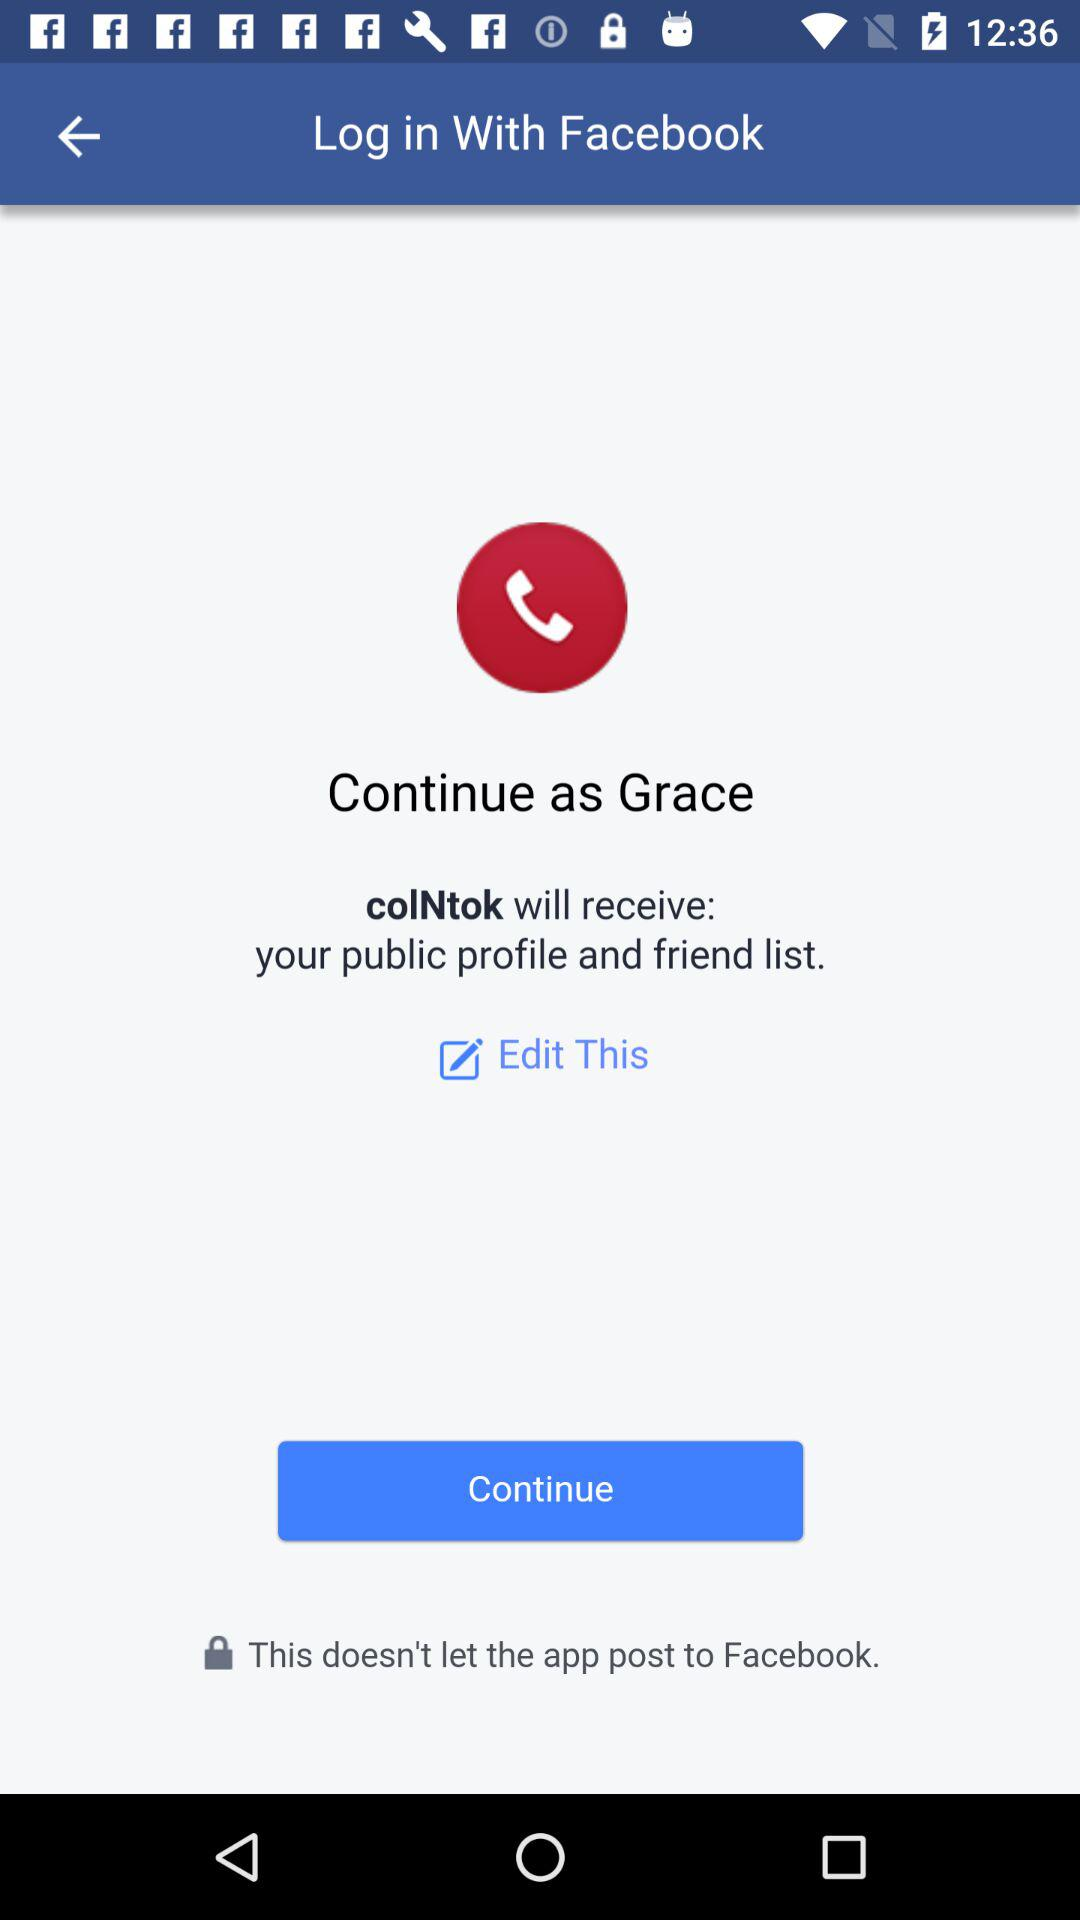What's the name of the user by whom the application can be continued? The name of the user is Grace. 